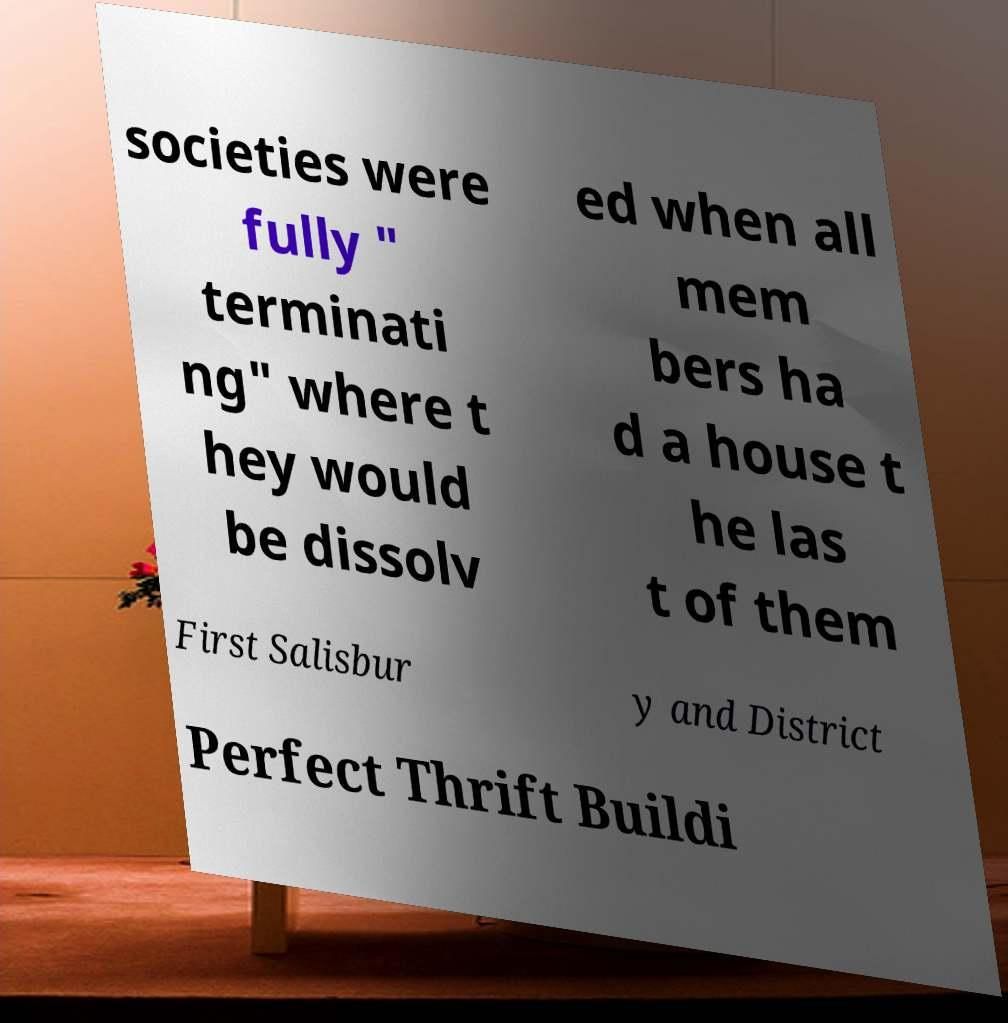Can you read and provide the text displayed in the image?This photo seems to have some interesting text. Can you extract and type it out for me? societies were fully " terminati ng" where t hey would be dissolv ed when all mem bers ha d a house t he las t of them First Salisbur y and District Perfect Thrift Buildi 